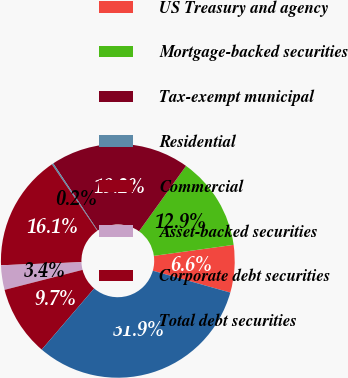Convert chart to OTSL. <chart><loc_0><loc_0><loc_500><loc_500><pie_chart><fcel>US Treasury and agency<fcel>Mortgage-backed securities<fcel>Tax-exempt municipal<fcel>Residential<fcel>Commercial<fcel>Asset-backed securities<fcel>Corporate debt securities<fcel>Total debt securities<nl><fcel>6.56%<fcel>12.9%<fcel>19.23%<fcel>0.23%<fcel>16.06%<fcel>3.39%<fcel>9.73%<fcel>31.9%<nl></chart> 